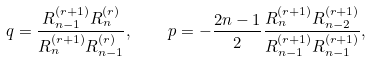<formula> <loc_0><loc_0><loc_500><loc_500>q = \frac { R _ { n - 1 } ^ { ( r + 1 ) } R _ { n } ^ { ( r ) } } { R _ { n } ^ { ( r + 1 ) } R _ { n - 1 } ^ { ( r ) } } , \quad p = - \frac { 2 n - 1 } { 2 } \frac { R _ { n } ^ { ( r + 1 ) } R _ { n - 2 } ^ { ( r + 1 ) } } { R _ { n - 1 } ^ { ( r + 1 ) } R _ { n - 1 } ^ { ( r + 1 ) } } ,</formula> 